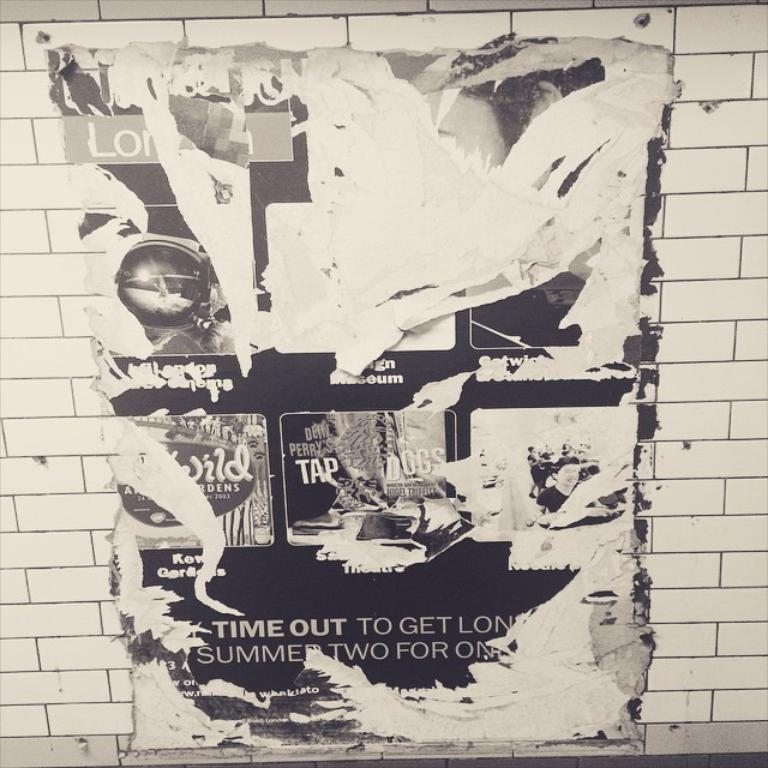What is the main subject in the center of the image? There is a poster in the center of the image. Where is the poster located? The poster is on a wall. What can be seen on the poster? There are pictures and text printed on the poster. What type of wall is visible in the background of the image? There is a brick wall in the background of the image. How many babies are shown on the poster, and what is their role in increasing the profit of the company? There are no babies shown on the poster, and the poster does not mention any company or profit. 